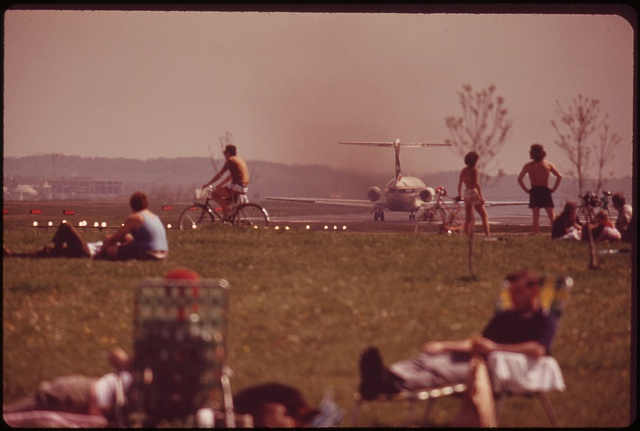Describe the objects in this image and their specific colors. I can see chair in black, maroon, and brown tones, people in black, maroon, and brown tones, people in black, maroon, brown, and pink tones, airplane in black, brown, maroon, and tan tones, and people in black, maroon, darkgray, and brown tones in this image. 